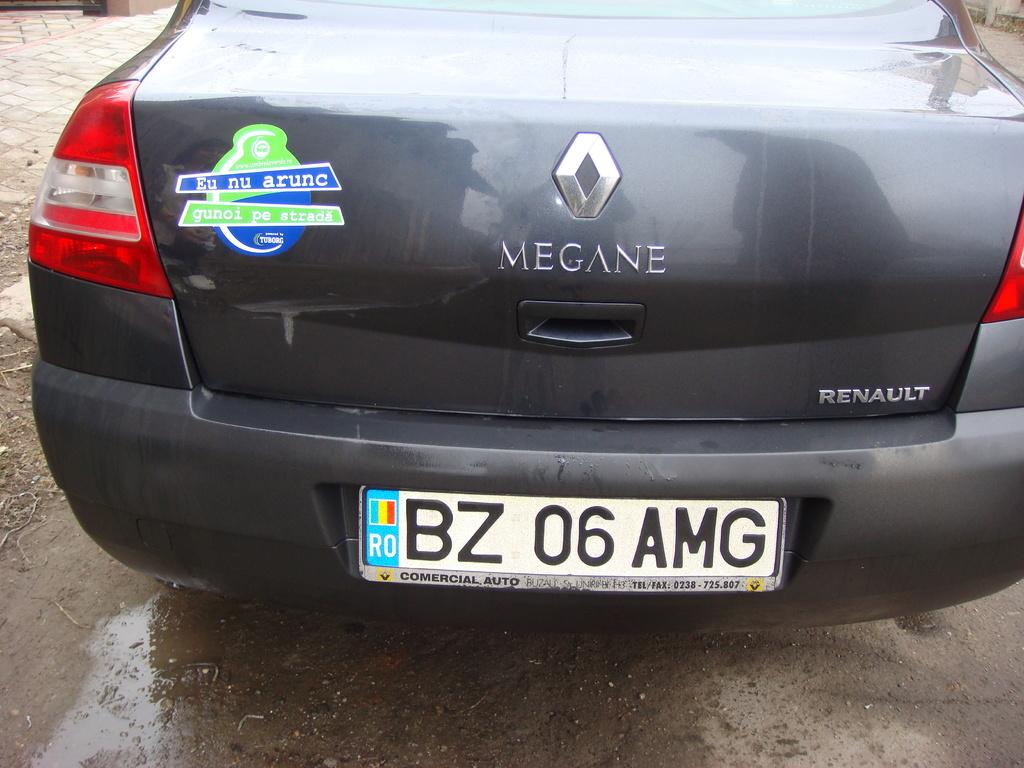Provide a one-sentence caption for the provided image. A black Renault is on a wet street. 